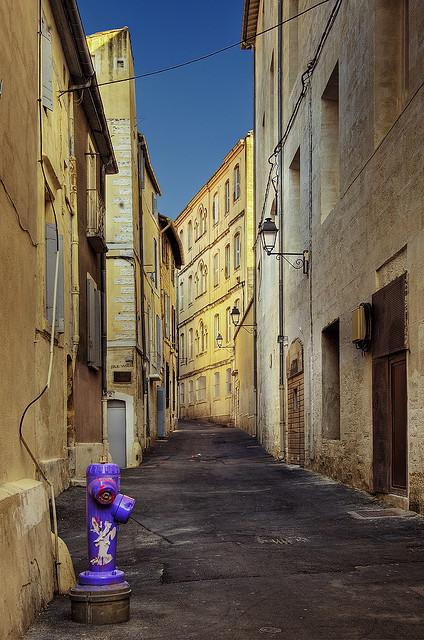Is there a stoop?
Write a very short answer. No. What has happened to the green waste bin?
Give a very brief answer. Nothing. Did someone forget the trash can outside?
Write a very short answer. No. Why is the fire hydrant purple?
Give a very brief answer. Paint. Do you see lots of garbage?
Concise answer only. No. Is this a big road?
Answer briefly. No. Is the hydrant between buildings?
Short answer required. Yes. Is there a park nearby?
Write a very short answer. No. Is it snowing in this scene?
Quick response, please. No. 